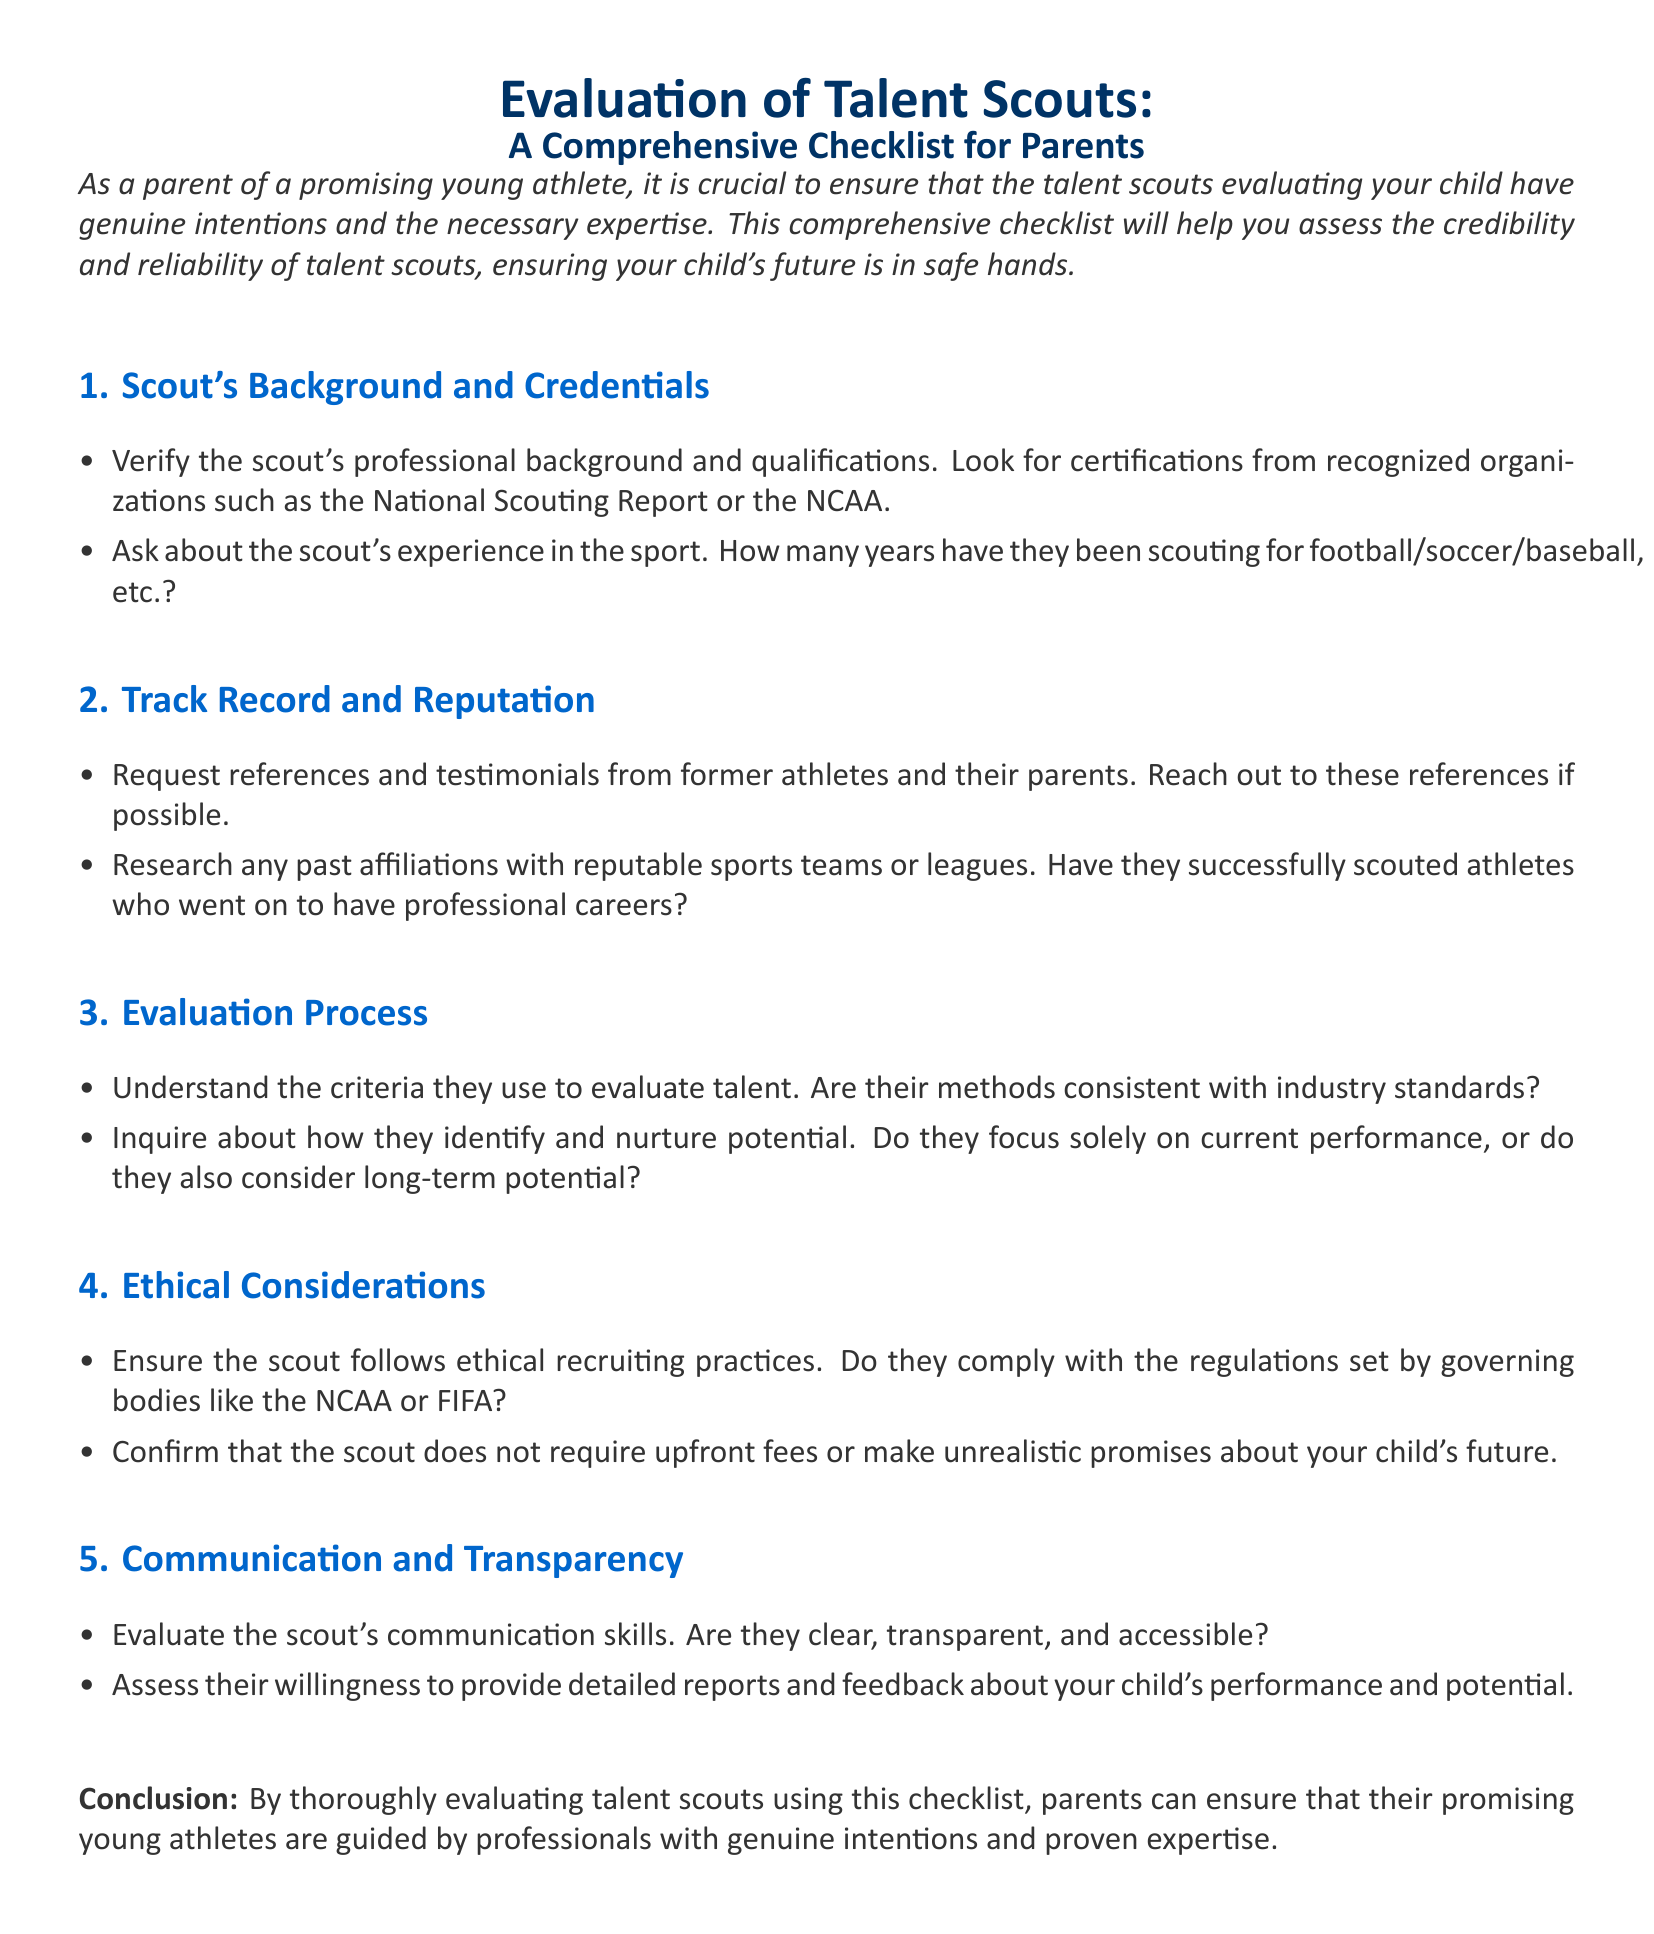what should parents verify about a scout's background? Parents should verify the scout's professional background and qualifications, looking for certifications from recognized organizations such as the National Scouting Report or the NCAA.
Answer: professional background and qualifications how can parents assess the scout's reputation? Parents can assess the scout's reputation by requesting references and testimonials from former athletes and their parents and researching past affiliations with reputable sports teams or leagues.
Answer: references and testimonials what is one aspect of the evaluation process to inquire about? Parents should inquire about the criteria the scout uses to evaluate talent and whether these methods are consistent with industry standards.
Answer: criteria for evaluating talent what must parents confirm about the scout's ethical practices? Parents must confirm that the scout follows ethical recruiting practices and does not require upfront fees or make unrealistic promises about their child's future.
Answer: ethical recruiting practices what is a key feature of good communication from the scout? A key feature of good communication from the scout is being clear, transparent, and accessible.
Answer: clear, transparent, and accessible how many years of experience should parents ask about? Parents should ask how many years the scout has been scouting for football, soccer, baseball, etc.
Answer: years of experience what does the document emphasize about the intention of scouts? The document emphasizes ensuring that the talent scouts evaluating their child have genuine intentions and the necessary expertise.
Answer: genuine intentions and necessary expertise what should parents assess regarding reports from the scout? Parents should assess the scout's willingness to provide detailed reports and feedback about their child's performance and potential.
Answer: willingness to provide detailed reports which governing bodies' regulations should scouts comply with? Scouts should comply with the regulations set by governing bodies like the NCAA or FIFA.
Answer: NCAA or FIFA 